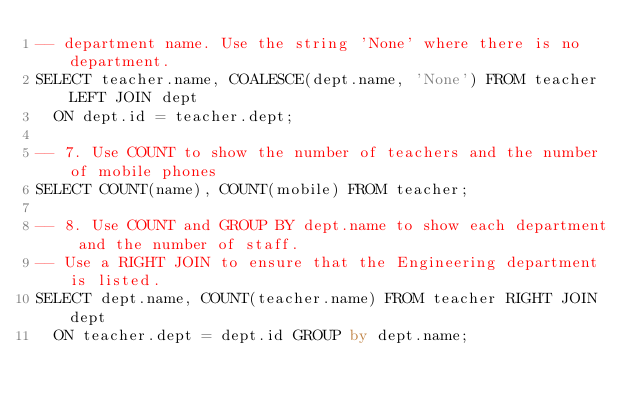Convert code to text. <code><loc_0><loc_0><loc_500><loc_500><_SQL_>-- department name. Use the string 'None' where there is no department.
SELECT teacher.name, COALESCE(dept.name, 'None') FROM teacher LEFT JOIN dept 
  ON dept.id = teacher.dept;

-- 7. Use COUNT to show the number of teachers and the number of mobile phones
SELECT COUNT(name), COUNT(mobile) FROM teacher;

-- 8. Use COUNT and GROUP BY dept.name to show each department and the number of staff. 
-- Use a RIGHT JOIN to ensure that the Engineering department is listed.
SELECT dept.name, COUNT(teacher.name) FROM teacher RIGHT JOIN dept 
  ON teacher.dept = dept.id GROUP by dept.name;
</code> 